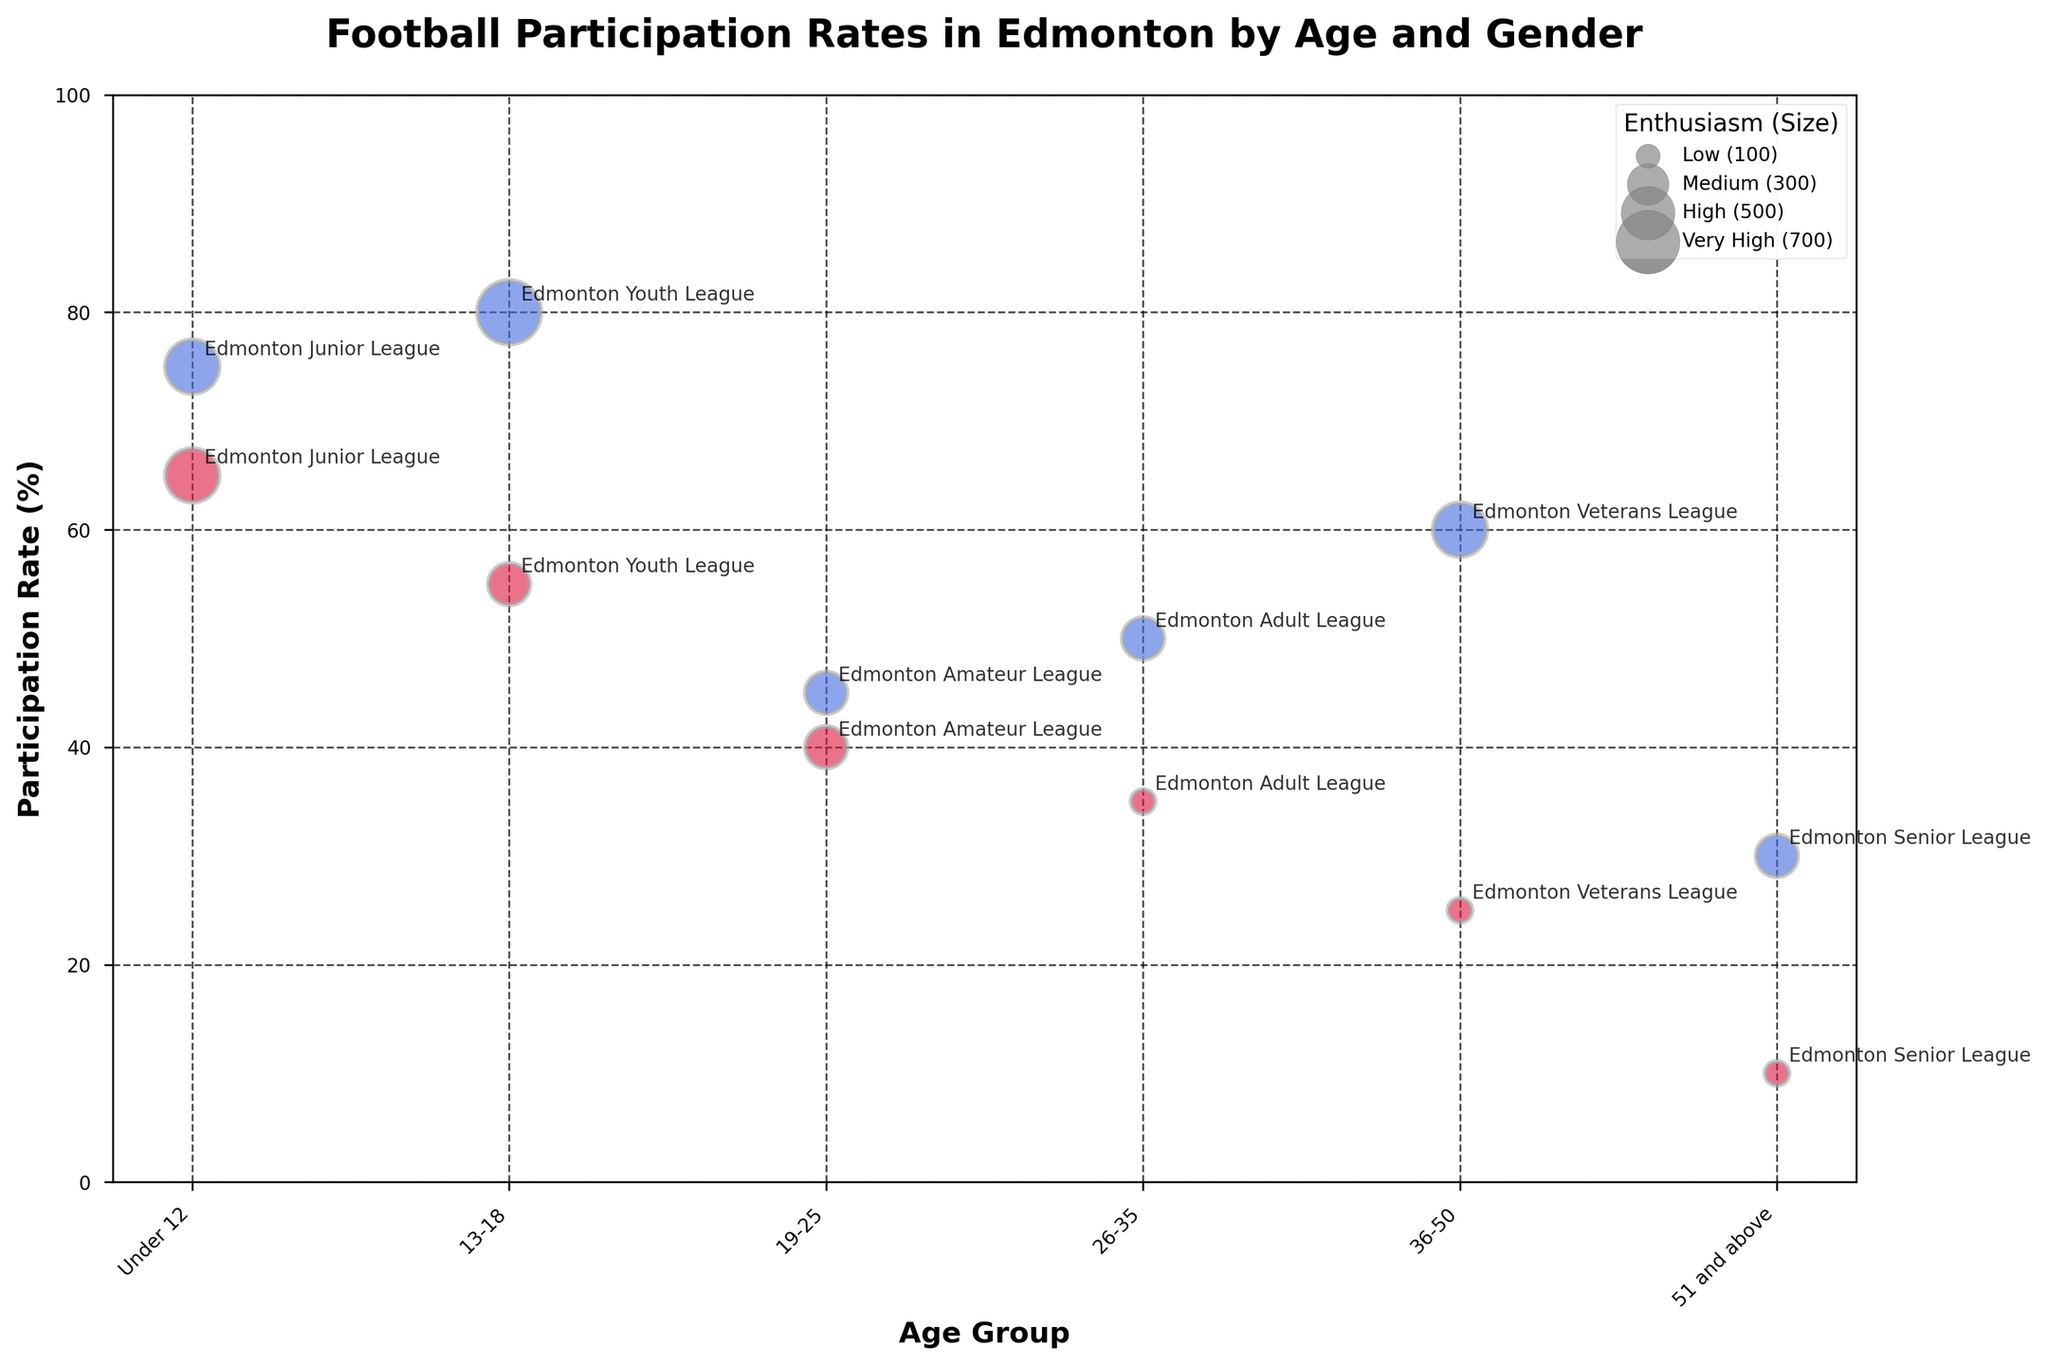What is the title of the figure? The title is located at the top of the plot and is prominently displayed in bold font. The figure title helps to understand the main topic that the visualization addresses.
Answer: Football Participation Rates in Edmonton by Age and Gender Which age group has the highest male participation rate? Look for the largest value on the y-axis correlated to the 'Male' bubbles. The x-axis will show the respective age group.
Answer: 13-18 What league corresponds to the lowest female participation rate? Identify the smallest bubble among the 'Female' bubbles, then check the annotation next to it for the league name.
Answer: Edmonton Senior League Compare the participation rates of males and females in the age group 19-25. Locate the 19-25 age group on the x-axis, find both 'Male' and 'Female' bubbles, then compare their positions on the y-axis. The male participation rate is higher.
Answer: Male: 45%, Female: 40% Which gender shows higher enthusiasm levels in the 13-18 age group? Check the sizes of the bubbles for both genders in the 13-18 age group. Larger bubbles indicate higher enthusiasm. Males have higher enthusiasm indicated by very high enthusiasm.
Answer: Male What is the average participation rate for females across all age groups? Sum the participation rates for all female age groups (65 + 55 + 40 + 35 + 25 + 10) and then divide by the number of age groups (6). The calculation is (65 + 55 + 40 + 35 + 25 + 10) / 6 = 230 / 6 ≈ 38.33.
Answer: 38.33% In which age group is the participation rate difference between males and females the largest? Calculate the absolute difference in participation rates for each age group from the figure and find the largest one. For 36-50, the difference is 60 - 25 = 35, which is the largest.
Answer: 36-50 Which league has the highest enthusiasm level among males? Find the 'Male' bubble with the largest size, and read the league annotation next to it. The bubble for the 13-18 age group, Edmonton Youth League, is the largest.
Answer: Edmonton Youth League Are there any age groups where females participate more than males? Compare the participation rates of both genders across all age groups. No female participation rate exceeds the corresponding male rate in any age group.
Answer: No Rank the age groups for males in descending order based on participation rates. Read and list the participation rates of males for each age group and then sort them from highest to lowest. The sequence is: 13-18 (80%), 36-50 (60%), Under 12 (75%), 26-35 (50%), 19-25 (45%), 51 and above (30%).
Answer: 13-18, Under 12, 36-50, 26-35, 19-25, 51 and above 